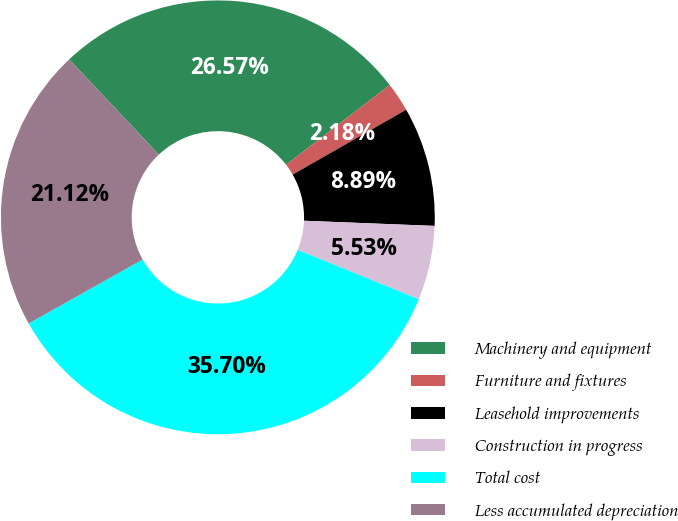<chart> <loc_0><loc_0><loc_500><loc_500><pie_chart><fcel>Machinery and equipment<fcel>Furniture and fixtures<fcel>Leasehold improvements<fcel>Construction in progress<fcel>Total cost<fcel>Less accumulated depreciation<nl><fcel>26.57%<fcel>2.18%<fcel>8.89%<fcel>5.53%<fcel>35.7%<fcel>21.12%<nl></chart> 